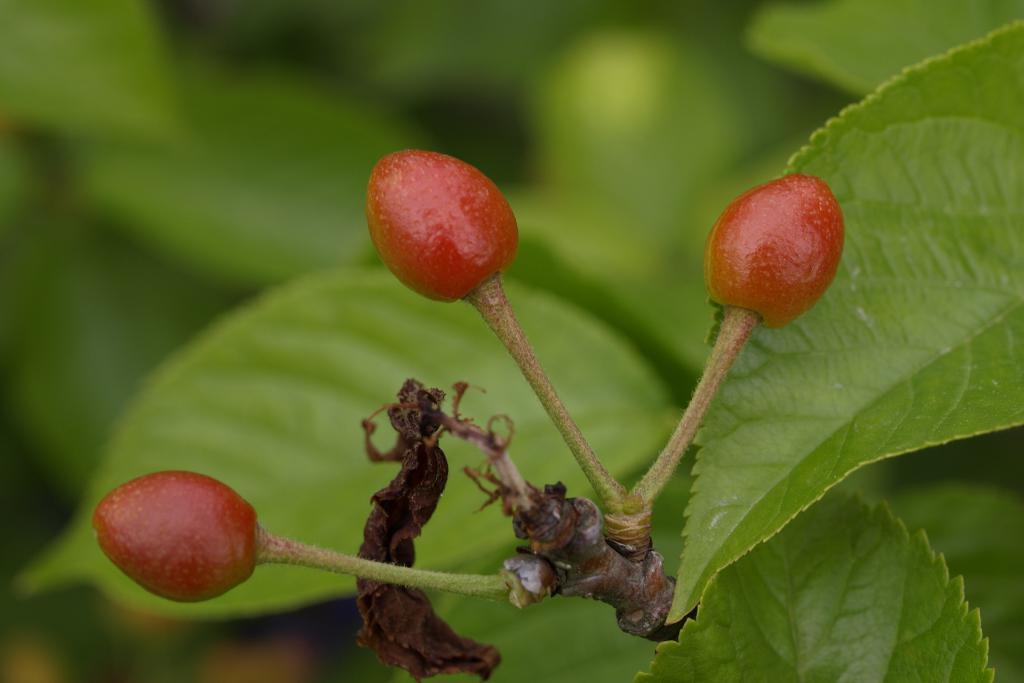How would you summarize this image in a sentence or two? In this picture I can see the red color things in front and I see the green leaves. I see that it is blurred in the background. 